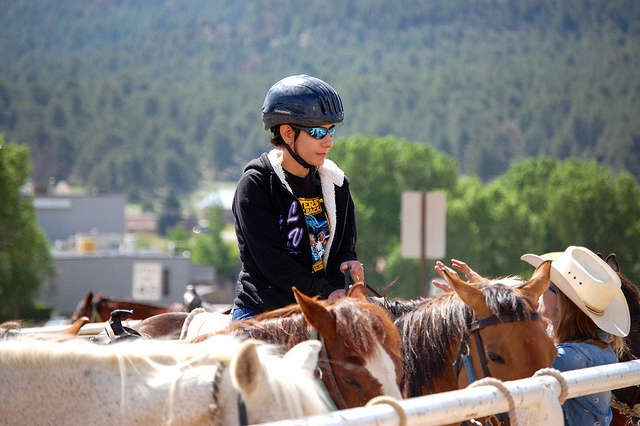Describe the objects in this image and their specific colors. I can see horse in gray, white, darkgray, and tan tones, people in gray, black, lightgray, and navy tones, horse in gray, maroon, black, and brown tones, horse in gray, maroon, brown, tan, and lightgray tones, and people in gray, ivory, black, and tan tones in this image. 